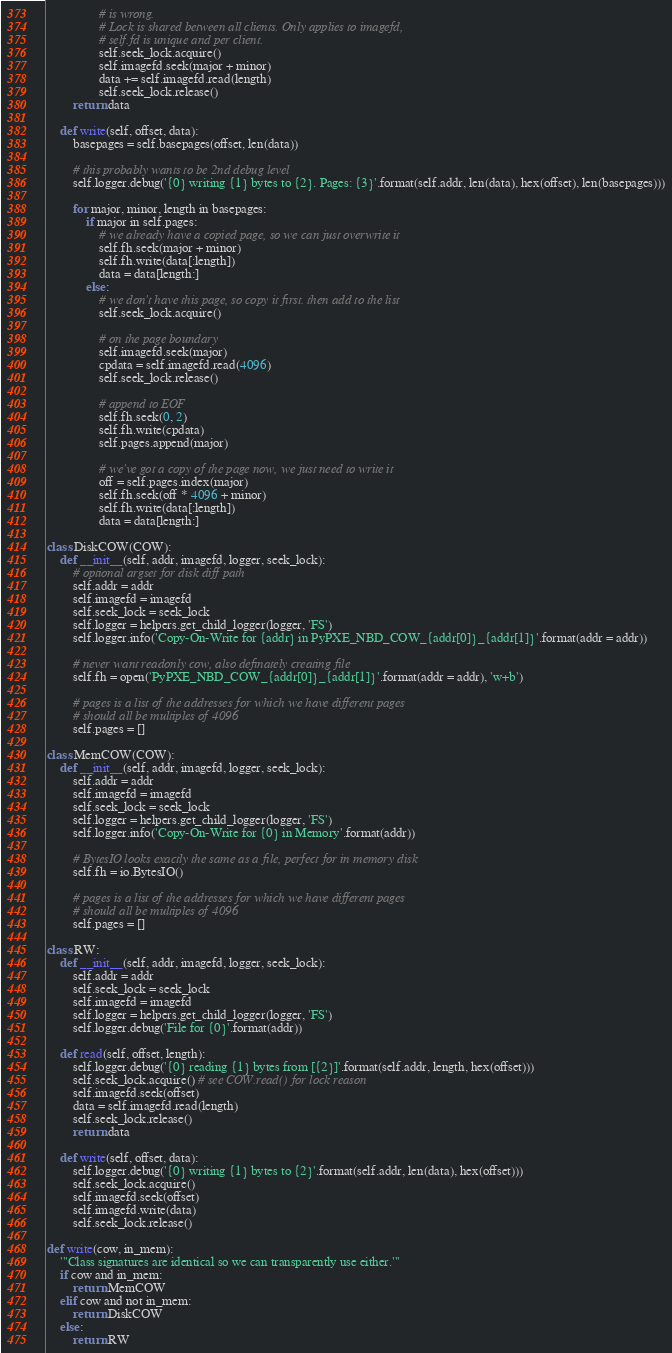Convert code to text. <code><loc_0><loc_0><loc_500><loc_500><_Python_>                # is wrong.
                # Lock is shared between all clients. Only applies to imagefd,
                # self.fd is unique and per client.
                self.seek_lock.acquire()
                self.imagefd.seek(major + minor)
                data += self.imagefd.read(length)
                self.seek_lock.release()
        return data

    def write(self, offset, data):
        basepages = self.basepages(offset, len(data))

        # this probably wants to be 2nd debug level
        self.logger.debug('{0} writing {1} bytes to {2}. Pages: {3}'.format(self.addr, len(data), hex(offset), len(basepages)))

        for major, minor, length in basepages:
            if major in self.pages:
                # we already have a copied page, so we can just overwrite it
                self.fh.seek(major + minor)
                self.fh.write(data[:length])
                data = data[length:]
            else:
                # we don't have this page, so copy it first. then add to the list
                self.seek_lock.acquire()

                # on the page boundary
                self.imagefd.seek(major)
                cpdata = self.imagefd.read(4096)
                self.seek_lock.release()

                # append to EOF
                self.fh.seek(0, 2)
                self.fh.write(cpdata)
                self.pages.append(major)

                # we've got a copy of the page now, we just need to write it
                off = self.pages.index(major)
                self.fh.seek(off * 4096 + minor)
                self.fh.write(data[:length])
                data = data[length:]

class DiskCOW(COW):
    def __init__(self, addr, imagefd, logger, seek_lock):
        # optional argset for disk diff path
        self.addr = addr
        self.imagefd = imagefd
        self.seek_lock = seek_lock
        self.logger = helpers.get_child_logger(logger, 'FS')
        self.logger.info('Copy-On-Write for {addr} in PyPXE_NBD_COW_{addr[0]}_{addr[1]}'.format(addr = addr))

        # never want readonly cow, also definately creating file
        self.fh = open('PyPXE_NBD_COW_{addr[0]}_{addr[1]}'.format(addr = addr), 'w+b')

        # pages is a list of the addresses for which we have different pages
        # should all be multiples of 4096
        self.pages = []

class MemCOW(COW):
    def __init__(self, addr, imagefd, logger, seek_lock):
        self.addr = addr
        self.imagefd = imagefd
        self.seek_lock = seek_lock
        self.logger = helpers.get_child_logger(logger, 'FS')
        self.logger.info('Copy-On-Write for {0} in Memory'.format(addr))

        # BytesIO looks exactly the same as a file, perfect for in memory disk
        self.fh = io.BytesIO()

        # pages is a list of the addresses for which we have different pages
        # should all be multiples of 4096
        self.pages = []

class RW:
    def __init__(self, addr, imagefd, logger, seek_lock):
        self.addr = addr
        self.seek_lock = seek_lock
        self.imagefd = imagefd
        self.logger = helpers.get_child_logger(logger, 'FS')
        self.logger.debug('File for {0}'.format(addr))

    def read(self, offset, length):
        self.logger.debug('{0} reading {1} bytes from [{2}]'.format(self.addr, length, hex(offset)))
        self.seek_lock.acquire() # see COW.read() for lock reason
        self.imagefd.seek(offset)
        data = self.imagefd.read(length)
        self.seek_lock.release()
        return data

    def write(self, offset, data):
        self.logger.debug('{0} writing {1} bytes to {2}'.format(self.addr, len(data), hex(offset)))
        self.seek_lock.acquire()
        self.imagefd.seek(offset)
        self.imagefd.write(data)
        self.seek_lock.release()

def write(cow, in_mem):
    '''Class signatures are identical so we can transparently use either.'''
    if cow and in_mem:
        return MemCOW
    elif cow and not in_mem:
        return DiskCOW
    else:
        return RW
</code> 